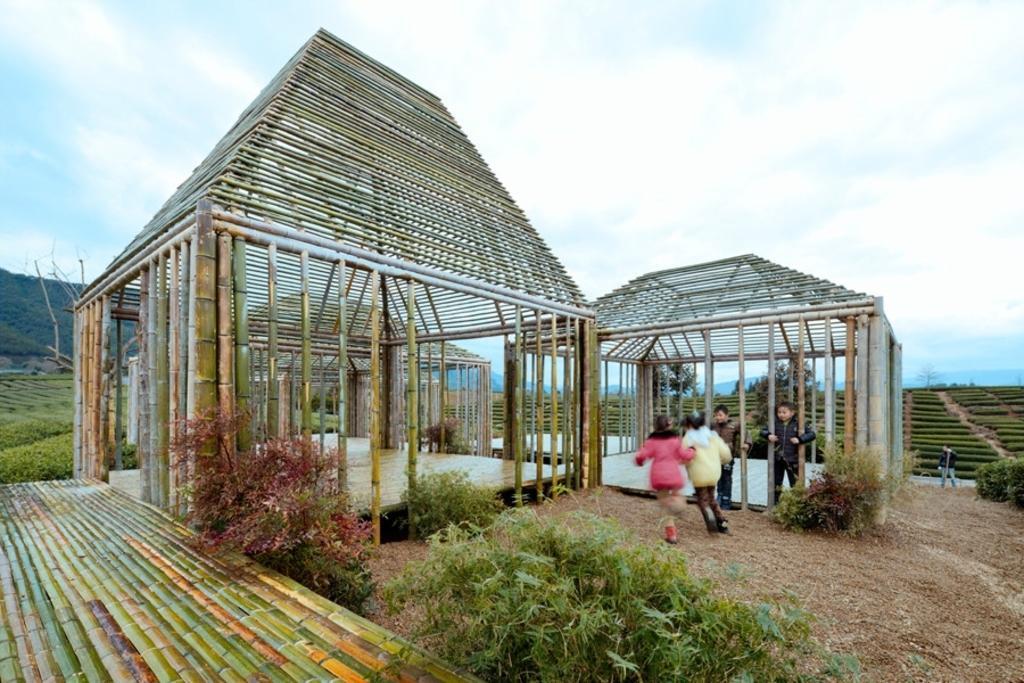Could you give a brief overview of what you see in this image? In the image in the center we can see bamboo architecture. And we can see grass,plants and few people were standing. In the background we can see the sky,clouds,hills,plants and grass. 